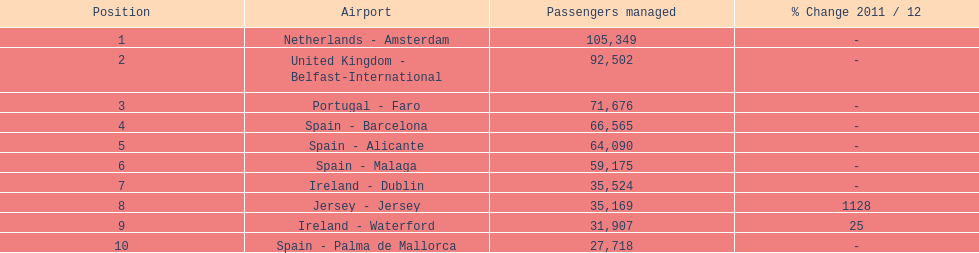Name all the london southend airports that did not list a change in 2001/12. Netherlands - Amsterdam, United Kingdom - Belfast-International, Portugal - Faro, Spain - Barcelona, Spain - Alicante, Spain - Malaga, Ireland - Dublin, Spain - Palma de Mallorca. What unchanged percentage airports from 2011/12 handled less then 50,000 passengers? Ireland - Dublin, Spain - Palma de Mallorca. What unchanged percentage airport from 2011/12 handled less then 50,000 passengers is the closest to the equator? Spain - Palma de Mallorca. 